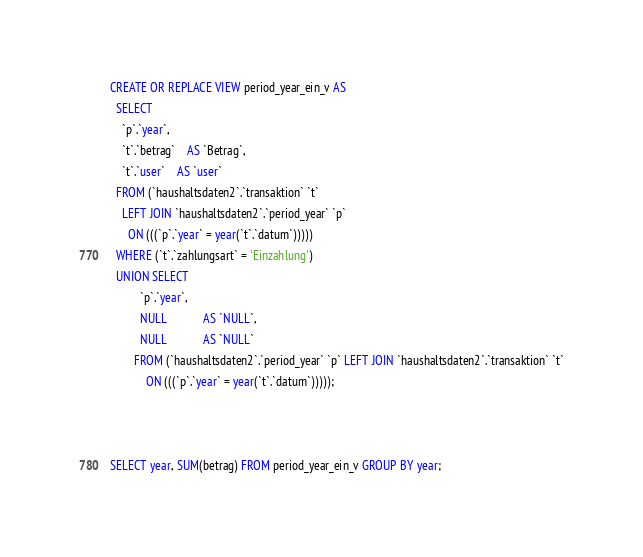Convert code to text. <code><loc_0><loc_0><loc_500><loc_500><_SQL_>CREATE OR REPLACE VIEW period_year_ein_v AS
  SELECT
    `p`.`year`,
    `t`.`betrag`    AS `Betrag`,
    `t`.`user`    AS `user`
  FROM (`haushaltsdaten2`.`transaktion` `t`
    LEFT JOIN `haushaltsdaten2`.`period_year` `p`
      ON (((`p`.`year` = year(`t`.`datum`)))))
  WHERE (`t`.`zahlungsart` = 'Einzahlung')
  UNION SELECT
          `p`.`year`,
          NULL            AS `NULL`,
          NULL            AS `NULL`
        FROM (`haushaltsdaten2`.`period_year` `p` LEFT JOIN `haushaltsdaten2`.`transaktion` `t`
            ON (((`p`.`year` = year(`t`.`datum`)))));



SELECT year, SUM(betrag) FROM period_year_ein_v GROUP BY year;
</code> 